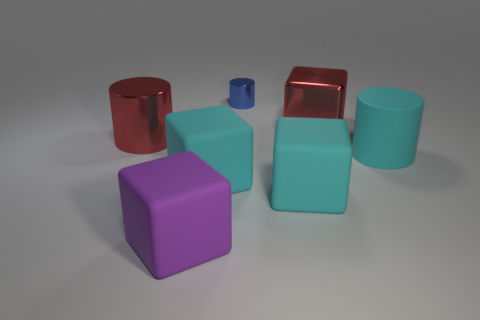Are there more matte cubes on the right side of the big purple object than large matte cylinders behind the large red cylinder?
Your response must be concise. Yes. What material is the large cylinder that is in front of the big red object to the left of the big metallic object on the right side of the purple rubber thing?
Give a very brief answer. Rubber. Is the shape of the small blue object behind the purple block the same as the large metal object to the left of the tiny blue metal thing?
Make the answer very short. Yes. Is there a red object of the same size as the cyan cylinder?
Offer a terse response. Yes. What number of cyan objects are either large metal objects or small metallic things?
Keep it short and to the point. 0. How many shiny cubes are the same color as the large metallic cylinder?
Your response must be concise. 1. How many cubes are large purple things or cyan objects?
Keep it short and to the point. 3. What color is the large cylinder to the left of the large matte cylinder?
Make the answer very short. Red. There is a purple rubber thing that is the same size as the cyan cylinder; what shape is it?
Provide a short and direct response. Cube. There is a large matte cylinder; what number of big purple cubes are in front of it?
Your answer should be compact. 1. 